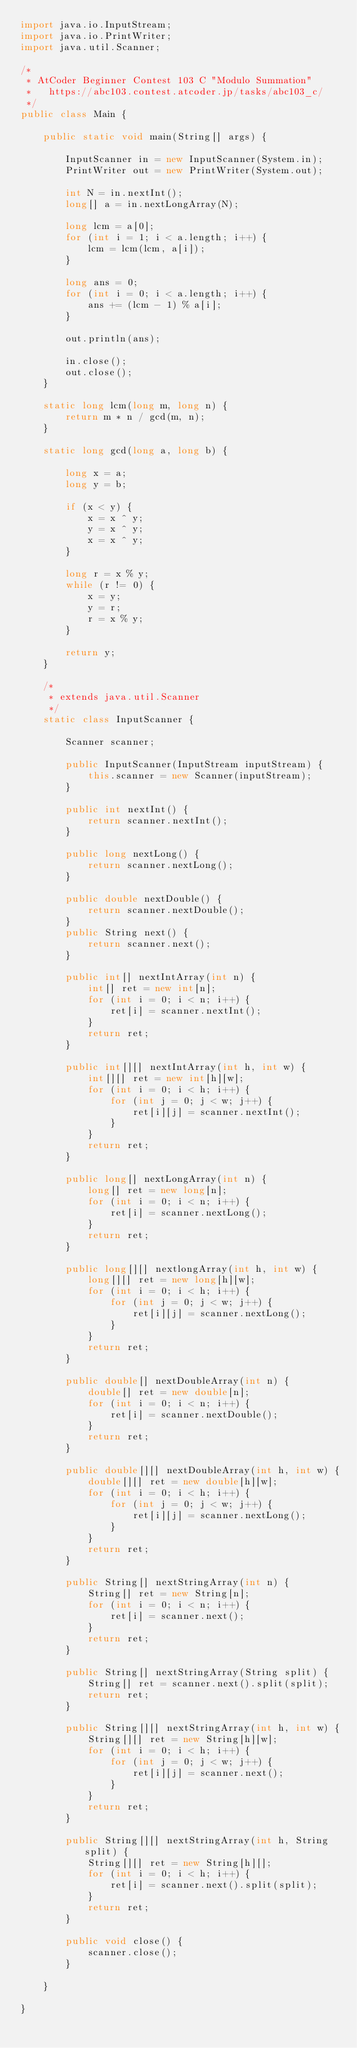<code> <loc_0><loc_0><loc_500><loc_500><_Java_>import java.io.InputStream;
import java.io.PrintWriter;
import java.util.Scanner;

/*
 * AtCoder Beginner Contest 103 C "Modulo Summation"
 *   https://abc103.contest.atcoder.jp/tasks/abc103_c/
 */
public class Main {

	public static void main(String[] args) {

		InputScanner in = new InputScanner(System.in);
		PrintWriter out = new PrintWriter(System.out);

		int N = in.nextInt();
		long[] a = in.nextLongArray(N);

		long lcm = a[0];
		for (int i = 1; i < a.length; i++) {
			lcm = lcm(lcm, a[i]);
		}

		long ans = 0;
		for (int i = 0; i < a.length; i++) {
			ans += (lcm - 1) % a[i];
		}

		out.println(ans);

		in.close();
		out.close();
	}

	static long lcm(long m, long n) {
	    return m * n / gcd(m, n);
	}

	static long gcd(long a, long b) {

		long x = a;
		long y = b;

		if (x < y) {
			x = x ^ y;
			y = x ^ y;
			x = x ^ y;
		}

		long r = x % y;
		while (r != 0) {
		    x = y;
		    y = r;
		    r = x % y;
		}

		return y;
	}

	/*
	 * extends java.util.Scanner
	 */
	static class InputScanner {

		Scanner scanner;

		public InputScanner(InputStream inputStream) {
			this.scanner = new Scanner(inputStream);
		}

		public int nextInt() {
			return scanner.nextInt();
		}

		public long nextLong() {
			return scanner.nextLong();
		}

		public double nextDouble() {
			return scanner.nextDouble();
		}
		public String next() {
			return scanner.next();
		}

		public int[] nextIntArray(int n) {
			int[] ret = new int[n];
			for (int i = 0; i < n; i++) {
				ret[i] = scanner.nextInt();
			}
			return ret;
		}

		public int[][] nextIntArray(int h, int w) {
			int[][] ret = new int[h][w];
			for (int i = 0; i < h; i++) {
				for (int j = 0; j < w; j++) {
					ret[i][j] = scanner.nextInt();
				}
			}
			return ret;
		}

		public long[] nextLongArray(int n) {
			long[] ret = new long[n];
			for (int i = 0; i < n; i++) {
				ret[i] = scanner.nextLong();
			}
			return ret;
		}

		public long[][] nextlongArray(int h, int w) {
			long[][] ret = new long[h][w];
			for (int i = 0; i < h; i++) {
				for (int j = 0; j < w; j++) {
					ret[i][j] = scanner.nextLong();
				}
			}
			return ret;
		}

		public double[] nextDoubleArray(int n) {
			double[] ret = new double[n];
			for (int i = 0; i < n; i++) {
				ret[i] = scanner.nextDouble();
			}
			return ret;
		}

		public double[][] nextDoubleArray(int h, int w) {
			double[][] ret = new double[h][w];
			for (int i = 0; i < h; i++) {
				for (int j = 0; j < w; j++) {
					ret[i][j] = scanner.nextLong();
				}
			}
			return ret;
		}

		public String[] nextStringArray(int n) {
			String[] ret = new String[n];
			for (int i = 0; i < n; i++) {
				ret[i] = scanner.next();
			}
			return ret;
		}

		public String[] nextStringArray(String split) {
			String[] ret = scanner.next().split(split);
			return ret;
		}

		public String[][] nextStringArray(int h, int w) {
			String[][] ret = new String[h][w];
			for (int i = 0; i < h; i++) {
				for (int j = 0; j < w; j++) {
					ret[i][j] = scanner.next();
				}
			}
			return ret;
		}

		public String[][] nextStringArray(int h, String split) {
			String[][] ret = new String[h][];
			for (int i = 0; i < h; i++) {
				ret[i] = scanner.next().split(split);
			}
			return ret;
		}

		public void close() {
			scanner.close();
		}

	}

}
</code> 